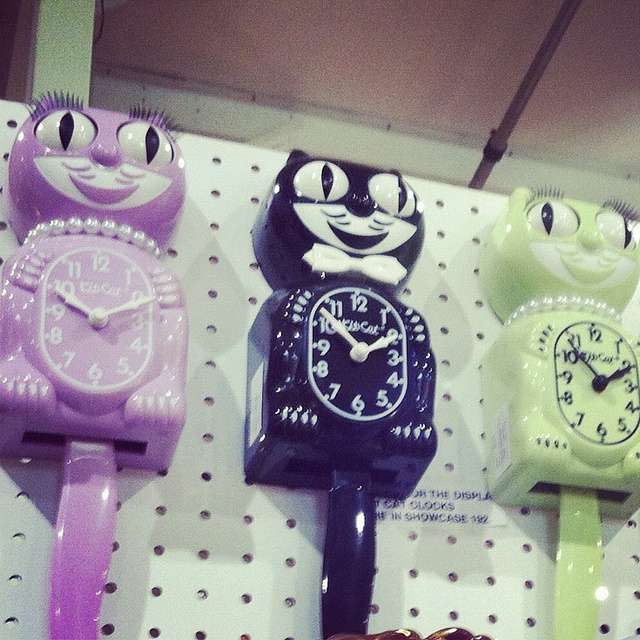Describe the objects in this image and their specific colors. I can see clock in black, darkgray, and lightgray tones, clock in black, navy, lightgray, and darkgray tones, clock in black, khaki, beige, darkgray, and gray tones, and tie in black, beige, darkgray, and gray tones in this image. 